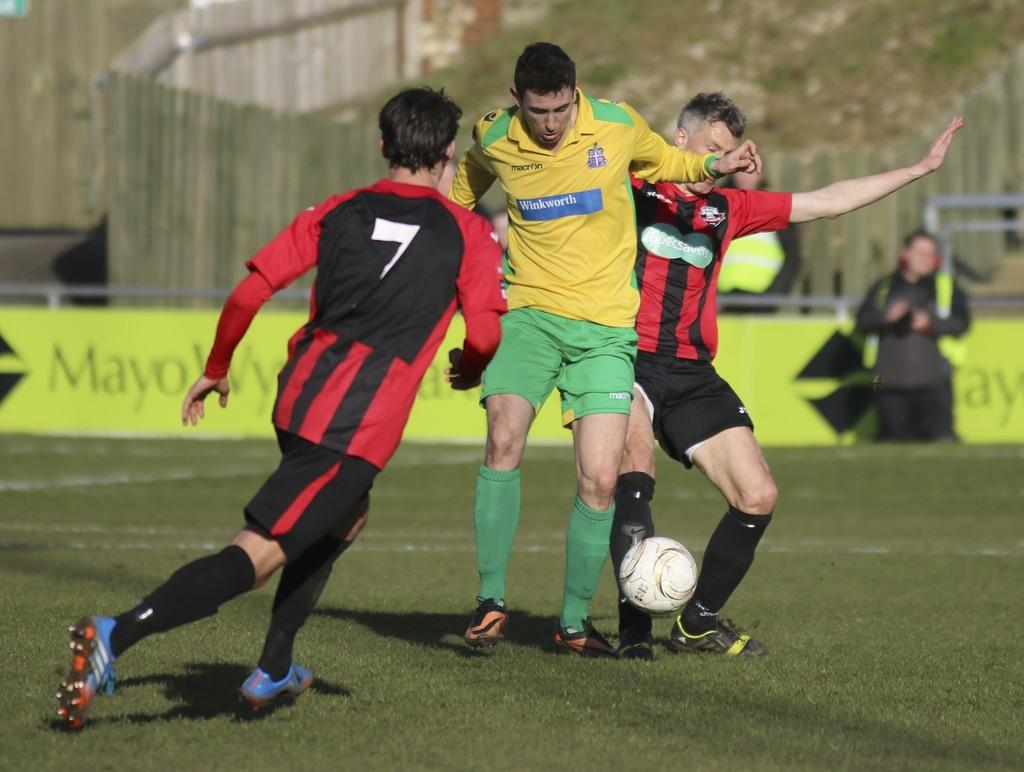What are the three people in the image doing? The three people in the image are playing football. What is the surface on which they are playing? There is a ground in the image. Are there any other people visible in the image? Yes, there are people present behind the football players. What can be seen in the background of the image? There are barricades and trees present in the image. What type of bell can be heard ringing in the image? There is no bell present or ringing in the image. What is the downtown area like in the image? The image does not depict a downtown area; it shows people playing football on a ground. 